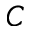Convert formula to latex. <formula><loc_0><loc_0><loc_500><loc_500>C</formula> 